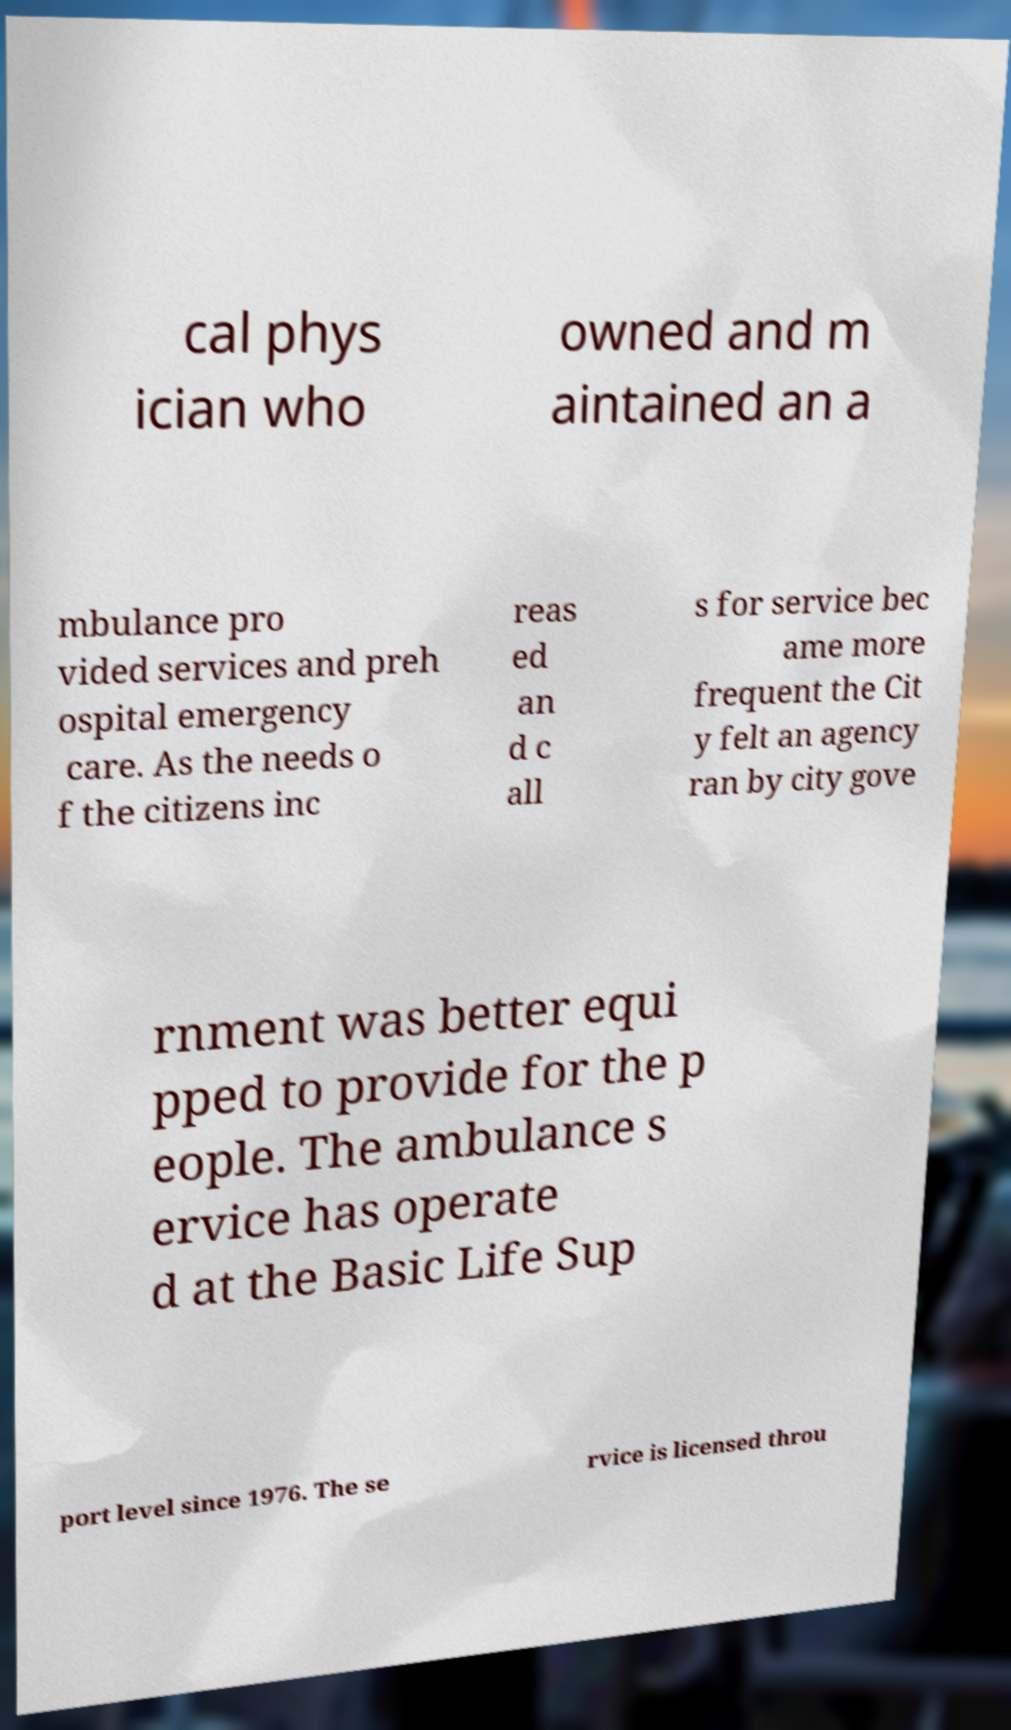Can you read and provide the text displayed in the image?This photo seems to have some interesting text. Can you extract and type it out for me? cal phys ician who owned and m aintained an a mbulance pro vided services and preh ospital emergency care. As the needs o f the citizens inc reas ed an d c all s for service bec ame more frequent the Cit y felt an agency ran by city gove rnment was better equi pped to provide for the p eople. The ambulance s ervice has operate d at the Basic Life Sup port level since 1976. The se rvice is licensed throu 